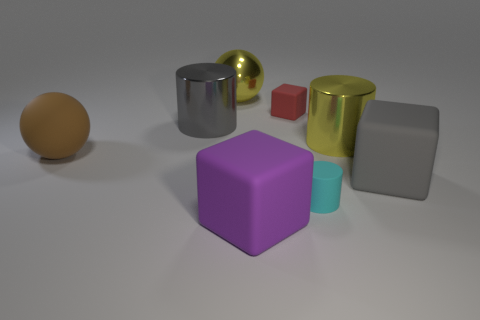How many large gray blocks have the same material as the tiny red cube? In the image, there is only one large gray block visible which appears to have a matte surface, similar to the material of the tiny red cube. Thus, one large gray block has the same material as the tiny red cube. 